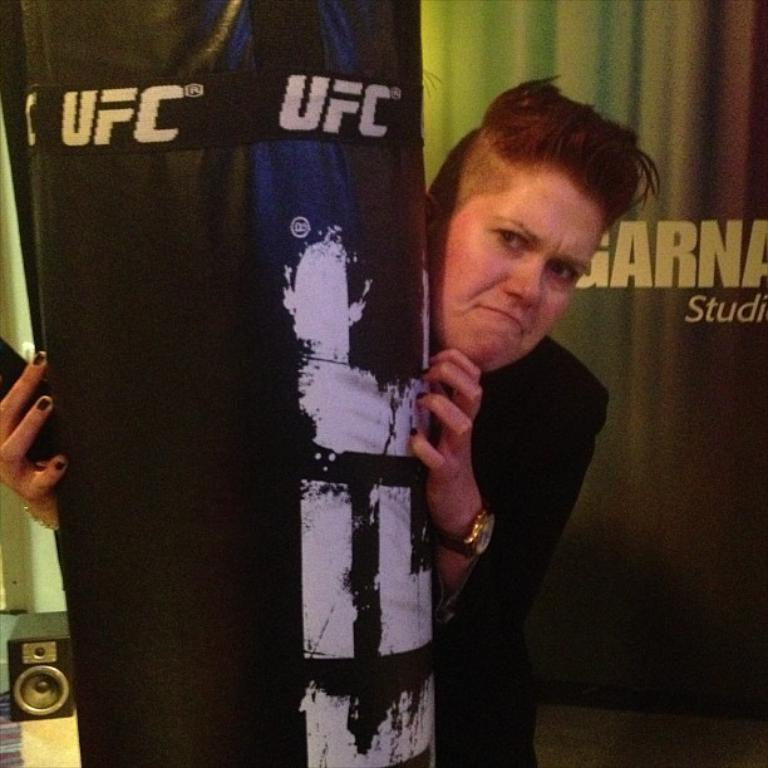Provide a one-sentence caption for the provided image. a woman standing behind a punching bag that says 'ufc' on it. 